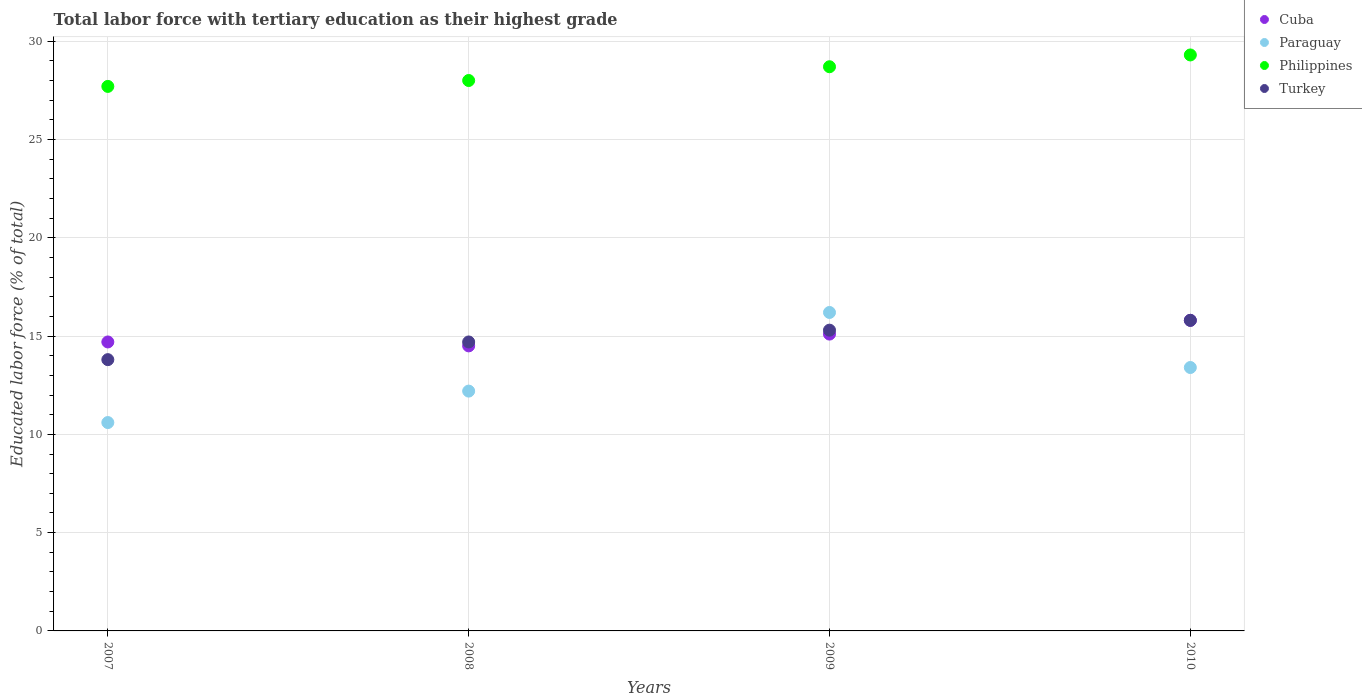What is the percentage of male labor force with tertiary education in Philippines in 2009?
Provide a short and direct response. 28.7. Across all years, what is the maximum percentage of male labor force with tertiary education in Cuba?
Make the answer very short. 15.8. Across all years, what is the minimum percentage of male labor force with tertiary education in Cuba?
Ensure brevity in your answer.  14.5. In which year was the percentage of male labor force with tertiary education in Paraguay maximum?
Ensure brevity in your answer.  2009. What is the total percentage of male labor force with tertiary education in Paraguay in the graph?
Offer a very short reply. 52.4. What is the difference between the percentage of male labor force with tertiary education in Turkey in 2008 and that in 2009?
Give a very brief answer. -0.6. What is the difference between the percentage of male labor force with tertiary education in Cuba in 2008 and the percentage of male labor force with tertiary education in Paraguay in 2009?
Provide a succinct answer. -1.7. What is the average percentage of male labor force with tertiary education in Turkey per year?
Your answer should be compact. 14.9. In the year 2010, what is the difference between the percentage of male labor force with tertiary education in Turkey and percentage of male labor force with tertiary education in Cuba?
Ensure brevity in your answer.  0. What is the ratio of the percentage of male labor force with tertiary education in Turkey in 2007 to that in 2009?
Provide a succinct answer. 0.9. Is the percentage of male labor force with tertiary education in Cuba in 2009 less than that in 2010?
Offer a terse response. Yes. What is the difference between the highest and the second highest percentage of male labor force with tertiary education in Philippines?
Offer a very short reply. 0.6. What is the difference between the highest and the lowest percentage of male labor force with tertiary education in Philippines?
Ensure brevity in your answer.  1.6. In how many years, is the percentage of male labor force with tertiary education in Paraguay greater than the average percentage of male labor force with tertiary education in Paraguay taken over all years?
Ensure brevity in your answer.  2. Is it the case that in every year, the sum of the percentage of male labor force with tertiary education in Turkey and percentage of male labor force with tertiary education in Paraguay  is greater than the sum of percentage of male labor force with tertiary education in Philippines and percentage of male labor force with tertiary education in Cuba?
Your answer should be compact. No. How many dotlines are there?
Ensure brevity in your answer.  4. What is the difference between two consecutive major ticks on the Y-axis?
Your answer should be very brief. 5. Are the values on the major ticks of Y-axis written in scientific E-notation?
Your answer should be compact. No. Where does the legend appear in the graph?
Your answer should be very brief. Top right. What is the title of the graph?
Offer a very short reply. Total labor force with tertiary education as their highest grade. What is the label or title of the X-axis?
Provide a short and direct response. Years. What is the label or title of the Y-axis?
Provide a short and direct response. Educated labor force (% of total). What is the Educated labor force (% of total) in Cuba in 2007?
Give a very brief answer. 14.7. What is the Educated labor force (% of total) in Paraguay in 2007?
Offer a terse response. 10.6. What is the Educated labor force (% of total) of Philippines in 2007?
Your response must be concise. 27.7. What is the Educated labor force (% of total) of Turkey in 2007?
Keep it short and to the point. 13.8. What is the Educated labor force (% of total) in Cuba in 2008?
Make the answer very short. 14.5. What is the Educated labor force (% of total) in Paraguay in 2008?
Make the answer very short. 12.2. What is the Educated labor force (% of total) of Turkey in 2008?
Offer a very short reply. 14.7. What is the Educated labor force (% of total) in Cuba in 2009?
Give a very brief answer. 15.1. What is the Educated labor force (% of total) of Paraguay in 2009?
Ensure brevity in your answer.  16.2. What is the Educated labor force (% of total) of Philippines in 2009?
Your answer should be very brief. 28.7. What is the Educated labor force (% of total) in Turkey in 2009?
Your answer should be compact. 15.3. What is the Educated labor force (% of total) of Cuba in 2010?
Make the answer very short. 15.8. What is the Educated labor force (% of total) of Paraguay in 2010?
Give a very brief answer. 13.4. What is the Educated labor force (% of total) of Philippines in 2010?
Offer a terse response. 29.3. What is the Educated labor force (% of total) of Turkey in 2010?
Ensure brevity in your answer.  15.8. Across all years, what is the maximum Educated labor force (% of total) in Cuba?
Your response must be concise. 15.8. Across all years, what is the maximum Educated labor force (% of total) of Paraguay?
Your answer should be very brief. 16.2. Across all years, what is the maximum Educated labor force (% of total) in Philippines?
Provide a short and direct response. 29.3. Across all years, what is the maximum Educated labor force (% of total) of Turkey?
Your answer should be compact. 15.8. Across all years, what is the minimum Educated labor force (% of total) in Cuba?
Ensure brevity in your answer.  14.5. Across all years, what is the minimum Educated labor force (% of total) in Paraguay?
Ensure brevity in your answer.  10.6. Across all years, what is the minimum Educated labor force (% of total) of Philippines?
Provide a succinct answer. 27.7. Across all years, what is the minimum Educated labor force (% of total) of Turkey?
Offer a terse response. 13.8. What is the total Educated labor force (% of total) of Cuba in the graph?
Your answer should be very brief. 60.1. What is the total Educated labor force (% of total) in Paraguay in the graph?
Provide a succinct answer. 52.4. What is the total Educated labor force (% of total) in Philippines in the graph?
Offer a very short reply. 113.7. What is the total Educated labor force (% of total) of Turkey in the graph?
Offer a terse response. 59.6. What is the difference between the Educated labor force (% of total) of Paraguay in 2007 and that in 2008?
Your answer should be compact. -1.6. What is the difference between the Educated labor force (% of total) in Turkey in 2007 and that in 2008?
Your answer should be very brief. -0.9. What is the difference between the Educated labor force (% of total) in Turkey in 2007 and that in 2009?
Ensure brevity in your answer.  -1.5. What is the difference between the Educated labor force (% of total) of Cuba in 2007 and that in 2010?
Ensure brevity in your answer.  -1.1. What is the difference between the Educated labor force (% of total) in Paraguay in 2007 and that in 2010?
Provide a succinct answer. -2.8. What is the difference between the Educated labor force (% of total) of Philippines in 2007 and that in 2010?
Offer a terse response. -1.6. What is the difference between the Educated labor force (% of total) of Turkey in 2007 and that in 2010?
Offer a terse response. -2. What is the difference between the Educated labor force (% of total) in Cuba in 2008 and that in 2009?
Provide a short and direct response. -0.6. What is the difference between the Educated labor force (% of total) of Paraguay in 2008 and that in 2009?
Keep it short and to the point. -4. What is the difference between the Educated labor force (% of total) in Philippines in 2008 and that in 2009?
Keep it short and to the point. -0.7. What is the difference between the Educated labor force (% of total) in Turkey in 2008 and that in 2009?
Ensure brevity in your answer.  -0.6. What is the difference between the Educated labor force (% of total) in Cuba in 2008 and that in 2010?
Give a very brief answer. -1.3. What is the difference between the Educated labor force (% of total) of Paraguay in 2008 and that in 2010?
Make the answer very short. -1.2. What is the difference between the Educated labor force (% of total) in Turkey in 2008 and that in 2010?
Offer a very short reply. -1.1. What is the difference between the Educated labor force (% of total) in Cuba in 2009 and that in 2010?
Give a very brief answer. -0.7. What is the difference between the Educated labor force (% of total) of Paraguay in 2009 and that in 2010?
Ensure brevity in your answer.  2.8. What is the difference between the Educated labor force (% of total) in Philippines in 2009 and that in 2010?
Offer a terse response. -0.6. What is the difference between the Educated labor force (% of total) of Turkey in 2009 and that in 2010?
Offer a very short reply. -0.5. What is the difference between the Educated labor force (% of total) of Cuba in 2007 and the Educated labor force (% of total) of Paraguay in 2008?
Your answer should be compact. 2.5. What is the difference between the Educated labor force (% of total) of Cuba in 2007 and the Educated labor force (% of total) of Turkey in 2008?
Provide a succinct answer. 0. What is the difference between the Educated labor force (% of total) in Paraguay in 2007 and the Educated labor force (% of total) in Philippines in 2008?
Your answer should be very brief. -17.4. What is the difference between the Educated labor force (% of total) in Paraguay in 2007 and the Educated labor force (% of total) in Turkey in 2008?
Give a very brief answer. -4.1. What is the difference between the Educated labor force (% of total) of Cuba in 2007 and the Educated labor force (% of total) of Paraguay in 2009?
Ensure brevity in your answer.  -1.5. What is the difference between the Educated labor force (% of total) of Cuba in 2007 and the Educated labor force (% of total) of Turkey in 2009?
Ensure brevity in your answer.  -0.6. What is the difference between the Educated labor force (% of total) of Paraguay in 2007 and the Educated labor force (% of total) of Philippines in 2009?
Provide a short and direct response. -18.1. What is the difference between the Educated labor force (% of total) of Cuba in 2007 and the Educated labor force (% of total) of Paraguay in 2010?
Offer a terse response. 1.3. What is the difference between the Educated labor force (% of total) in Cuba in 2007 and the Educated labor force (% of total) in Philippines in 2010?
Offer a very short reply. -14.6. What is the difference between the Educated labor force (% of total) of Paraguay in 2007 and the Educated labor force (% of total) of Philippines in 2010?
Your answer should be compact. -18.7. What is the difference between the Educated labor force (% of total) in Paraguay in 2007 and the Educated labor force (% of total) in Turkey in 2010?
Give a very brief answer. -5.2. What is the difference between the Educated labor force (% of total) of Cuba in 2008 and the Educated labor force (% of total) of Paraguay in 2009?
Your answer should be very brief. -1.7. What is the difference between the Educated labor force (% of total) of Cuba in 2008 and the Educated labor force (% of total) of Turkey in 2009?
Provide a succinct answer. -0.8. What is the difference between the Educated labor force (% of total) of Paraguay in 2008 and the Educated labor force (% of total) of Philippines in 2009?
Your answer should be compact. -16.5. What is the difference between the Educated labor force (% of total) of Paraguay in 2008 and the Educated labor force (% of total) of Turkey in 2009?
Offer a very short reply. -3.1. What is the difference between the Educated labor force (% of total) of Cuba in 2008 and the Educated labor force (% of total) of Philippines in 2010?
Offer a terse response. -14.8. What is the difference between the Educated labor force (% of total) of Cuba in 2008 and the Educated labor force (% of total) of Turkey in 2010?
Make the answer very short. -1.3. What is the difference between the Educated labor force (% of total) of Paraguay in 2008 and the Educated labor force (% of total) of Philippines in 2010?
Keep it short and to the point. -17.1. What is the difference between the Educated labor force (% of total) in Paraguay in 2008 and the Educated labor force (% of total) in Turkey in 2010?
Your answer should be very brief. -3.6. What is the difference between the Educated labor force (% of total) of Cuba in 2009 and the Educated labor force (% of total) of Philippines in 2010?
Provide a succinct answer. -14.2. What is the difference between the Educated labor force (% of total) of Paraguay in 2009 and the Educated labor force (% of total) of Turkey in 2010?
Provide a succinct answer. 0.4. What is the average Educated labor force (% of total) of Cuba per year?
Provide a succinct answer. 15.03. What is the average Educated labor force (% of total) of Paraguay per year?
Your answer should be compact. 13.1. What is the average Educated labor force (% of total) in Philippines per year?
Your answer should be compact. 28.43. What is the average Educated labor force (% of total) in Turkey per year?
Your answer should be compact. 14.9. In the year 2007, what is the difference between the Educated labor force (% of total) of Paraguay and Educated labor force (% of total) of Philippines?
Give a very brief answer. -17.1. In the year 2008, what is the difference between the Educated labor force (% of total) of Cuba and Educated labor force (% of total) of Paraguay?
Make the answer very short. 2.3. In the year 2008, what is the difference between the Educated labor force (% of total) of Paraguay and Educated labor force (% of total) of Philippines?
Keep it short and to the point. -15.8. In the year 2008, what is the difference between the Educated labor force (% of total) in Philippines and Educated labor force (% of total) in Turkey?
Keep it short and to the point. 13.3. In the year 2009, what is the difference between the Educated labor force (% of total) in Cuba and Educated labor force (% of total) in Philippines?
Offer a terse response. -13.6. In the year 2009, what is the difference between the Educated labor force (% of total) in Paraguay and Educated labor force (% of total) in Philippines?
Ensure brevity in your answer.  -12.5. In the year 2010, what is the difference between the Educated labor force (% of total) in Cuba and Educated labor force (% of total) in Philippines?
Offer a terse response. -13.5. In the year 2010, what is the difference between the Educated labor force (% of total) in Paraguay and Educated labor force (% of total) in Philippines?
Give a very brief answer. -15.9. In the year 2010, what is the difference between the Educated labor force (% of total) of Paraguay and Educated labor force (% of total) of Turkey?
Provide a succinct answer. -2.4. In the year 2010, what is the difference between the Educated labor force (% of total) of Philippines and Educated labor force (% of total) of Turkey?
Provide a short and direct response. 13.5. What is the ratio of the Educated labor force (% of total) of Cuba in 2007 to that in 2008?
Provide a succinct answer. 1.01. What is the ratio of the Educated labor force (% of total) of Paraguay in 2007 to that in 2008?
Ensure brevity in your answer.  0.87. What is the ratio of the Educated labor force (% of total) of Philippines in 2007 to that in 2008?
Keep it short and to the point. 0.99. What is the ratio of the Educated labor force (% of total) of Turkey in 2007 to that in 2008?
Your answer should be compact. 0.94. What is the ratio of the Educated labor force (% of total) of Cuba in 2007 to that in 2009?
Your response must be concise. 0.97. What is the ratio of the Educated labor force (% of total) of Paraguay in 2007 to that in 2009?
Your answer should be compact. 0.65. What is the ratio of the Educated labor force (% of total) of Philippines in 2007 to that in 2009?
Give a very brief answer. 0.97. What is the ratio of the Educated labor force (% of total) of Turkey in 2007 to that in 2009?
Give a very brief answer. 0.9. What is the ratio of the Educated labor force (% of total) in Cuba in 2007 to that in 2010?
Give a very brief answer. 0.93. What is the ratio of the Educated labor force (% of total) of Paraguay in 2007 to that in 2010?
Offer a very short reply. 0.79. What is the ratio of the Educated labor force (% of total) in Philippines in 2007 to that in 2010?
Your answer should be very brief. 0.95. What is the ratio of the Educated labor force (% of total) in Turkey in 2007 to that in 2010?
Offer a terse response. 0.87. What is the ratio of the Educated labor force (% of total) of Cuba in 2008 to that in 2009?
Provide a succinct answer. 0.96. What is the ratio of the Educated labor force (% of total) in Paraguay in 2008 to that in 2009?
Ensure brevity in your answer.  0.75. What is the ratio of the Educated labor force (% of total) in Philippines in 2008 to that in 2009?
Keep it short and to the point. 0.98. What is the ratio of the Educated labor force (% of total) of Turkey in 2008 to that in 2009?
Offer a terse response. 0.96. What is the ratio of the Educated labor force (% of total) of Cuba in 2008 to that in 2010?
Keep it short and to the point. 0.92. What is the ratio of the Educated labor force (% of total) of Paraguay in 2008 to that in 2010?
Offer a terse response. 0.91. What is the ratio of the Educated labor force (% of total) in Philippines in 2008 to that in 2010?
Provide a succinct answer. 0.96. What is the ratio of the Educated labor force (% of total) in Turkey in 2008 to that in 2010?
Provide a short and direct response. 0.93. What is the ratio of the Educated labor force (% of total) of Cuba in 2009 to that in 2010?
Keep it short and to the point. 0.96. What is the ratio of the Educated labor force (% of total) of Paraguay in 2009 to that in 2010?
Give a very brief answer. 1.21. What is the ratio of the Educated labor force (% of total) of Philippines in 2009 to that in 2010?
Give a very brief answer. 0.98. What is the ratio of the Educated labor force (% of total) of Turkey in 2009 to that in 2010?
Make the answer very short. 0.97. What is the difference between the highest and the second highest Educated labor force (% of total) in Cuba?
Ensure brevity in your answer.  0.7. What is the difference between the highest and the second highest Educated labor force (% of total) of Turkey?
Make the answer very short. 0.5. What is the difference between the highest and the lowest Educated labor force (% of total) in Cuba?
Offer a very short reply. 1.3. What is the difference between the highest and the lowest Educated labor force (% of total) of Turkey?
Offer a very short reply. 2. 